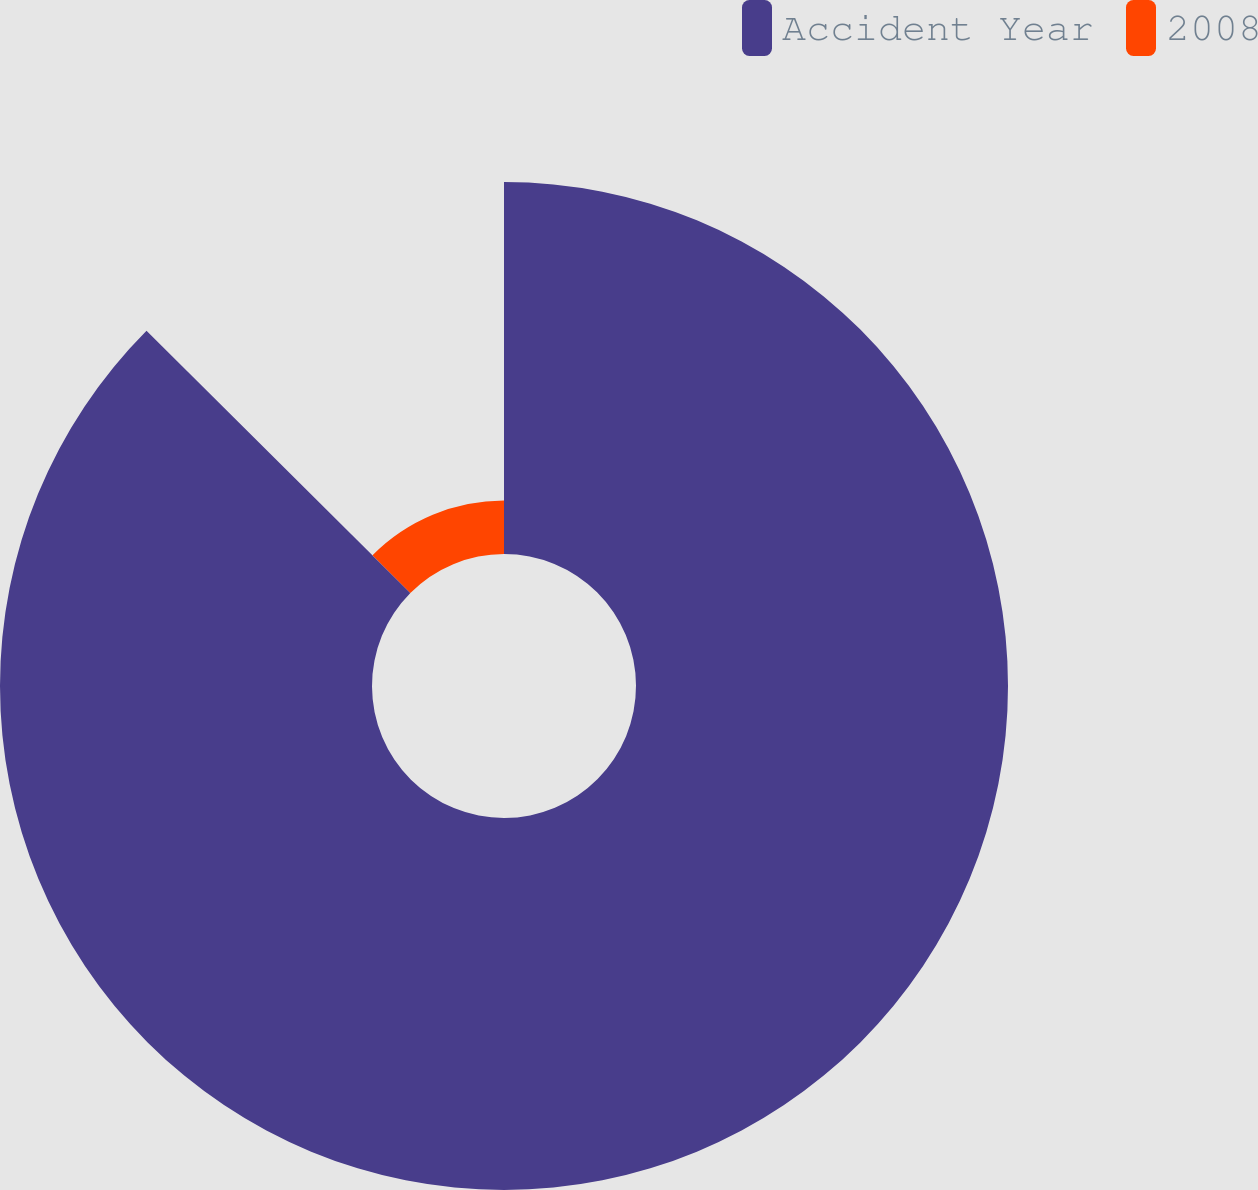Convert chart to OTSL. <chart><loc_0><loc_0><loc_500><loc_500><pie_chart><fcel>Accident Year<fcel>2008<nl><fcel>87.45%<fcel>12.55%<nl></chart> 